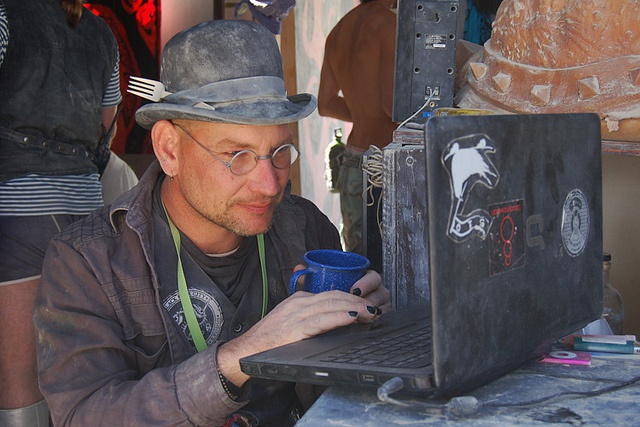Describe the objects in this image and their specific colors. I can see people in black, gray, brown, and darkgray tones, laptop in black and gray tones, people in black and gray tones, people in black, maroon, and gray tones, and cup in black, navy, blue, and darkblue tones in this image. 